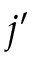<formula> <loc_0><loc_0><loc_500><loc_500>j ^ { \prime }</formula> 